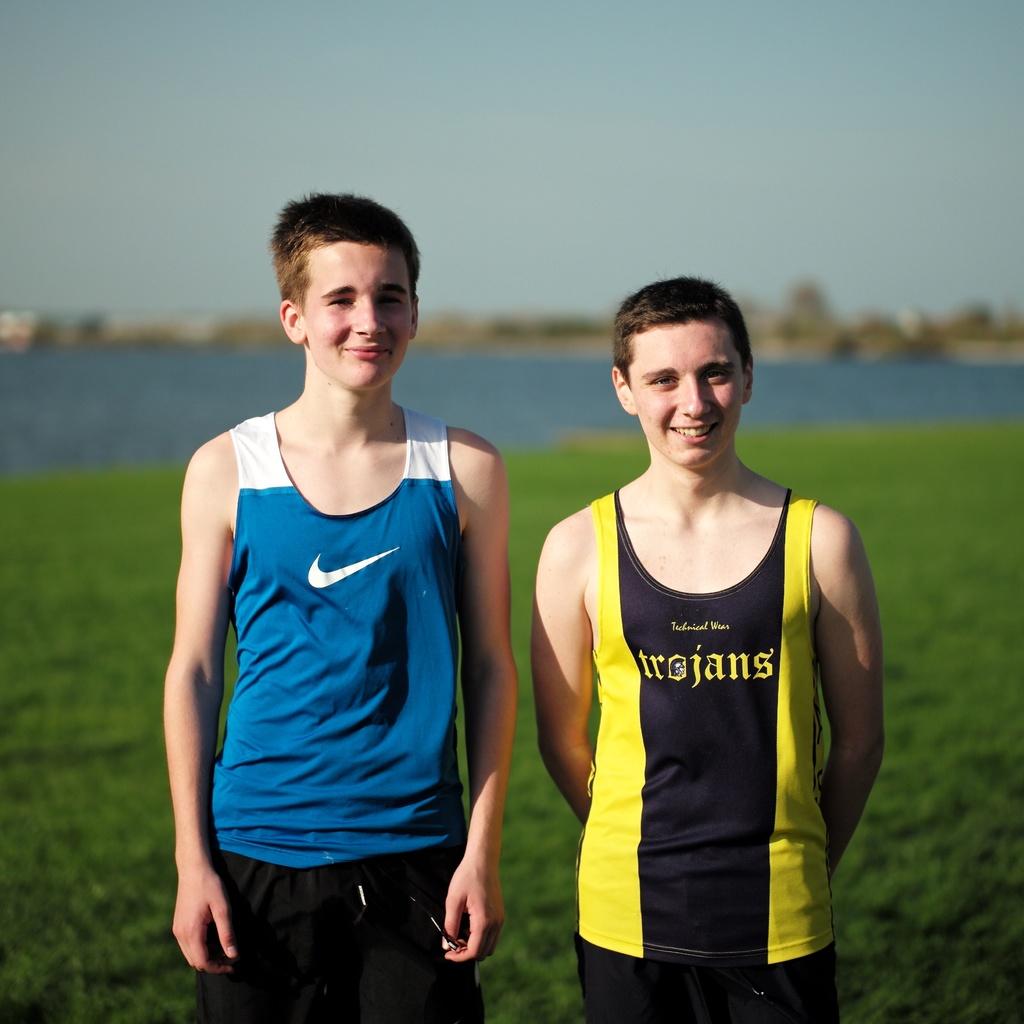What is the mascot name on the shirt?
Ensure brevity in your answer.  Trojans. 